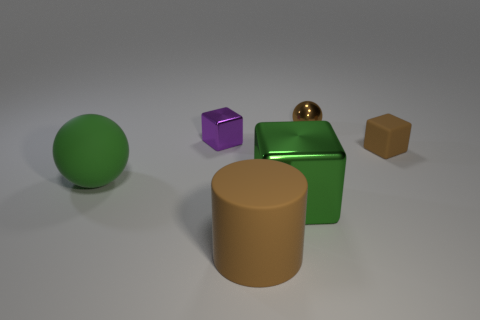How many things are small gray things or purple cubes?
Give a very brief answer. 1. Are there any large rubber balls that have the same color as the big block?
Offer a very short reply. Yes. How many big rubber things are on the left side of the large rubber thing right of the small purple thing?
Your response must be concise. 1. Is the number of small brown matte objects greater than the number of small purple shiny cylinders?
Provide a short and direct response. Yes. Are the small purple block and the large green cube made of the same material?
Ensure brevity in your answer.  Yes. Are there the same number of tiny purple objects in front of the large shiny object and large blue rubber cylinders?
Give a very brief answer. Yes. What number of tiny balls have the same material as the brown cube?
Ensure brevity in your answer.  0. Is the number of tiny brown shiny cylinders less than the number of brown shiny objects?
Your answer should be compact. Yes. Do the metallic block behind the small brown cube and the tiny ball have the same color?
Keep it short and to the point. No. How many matte things are to the left of the metal thing behind the tiny block left of the brown cylinder?
Offer a terse response. 2. 